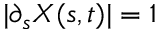<formula> <loc_0><loc_0><loc_500><loc_500>| \partial _ { s } { X } ( s , t ) | = 1</formula> 